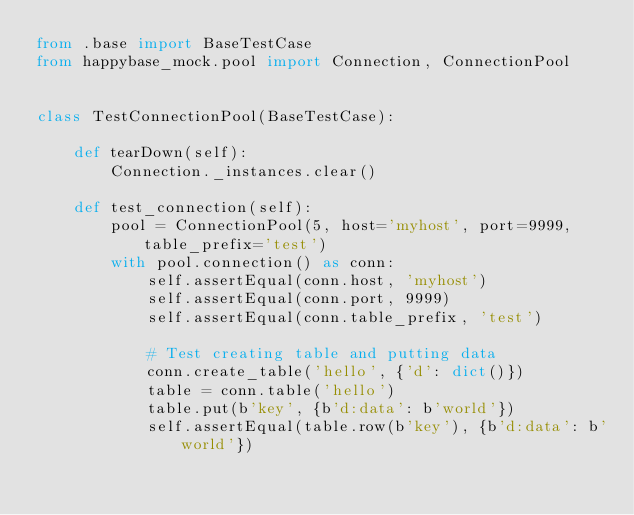Convert code to text. <code><loc_0><loc_0><loc_500><loc_500><_Python_>from .base import BaseTestCase
from happybase_mock.pool import Connection, ConnectionPool


class TestConnectionPool(BaseTestCase):

    def tearDown(self):
        Connection._instances.clear()

    def test_connection(self):
        pool = ConnectionPool(5, host='myhost', port=9999, table_prefix='test')
        with pool.connection() as conn:
            self.assertEqual(conn.host, 'myhost')
            self.assertEqual(conn.port, 9999)
            self.assertEqual(conn.table_prefix, 'test')

            # Test creating table and putting data
            conn.create_table('hello', {'d': dict()})
            table = conn.table('hello')
            table.put(b'key', {b'd:data': b'world'})
            self.assertEqual(table.row(b'key'), {b'd:data': b'world'})
</code> 